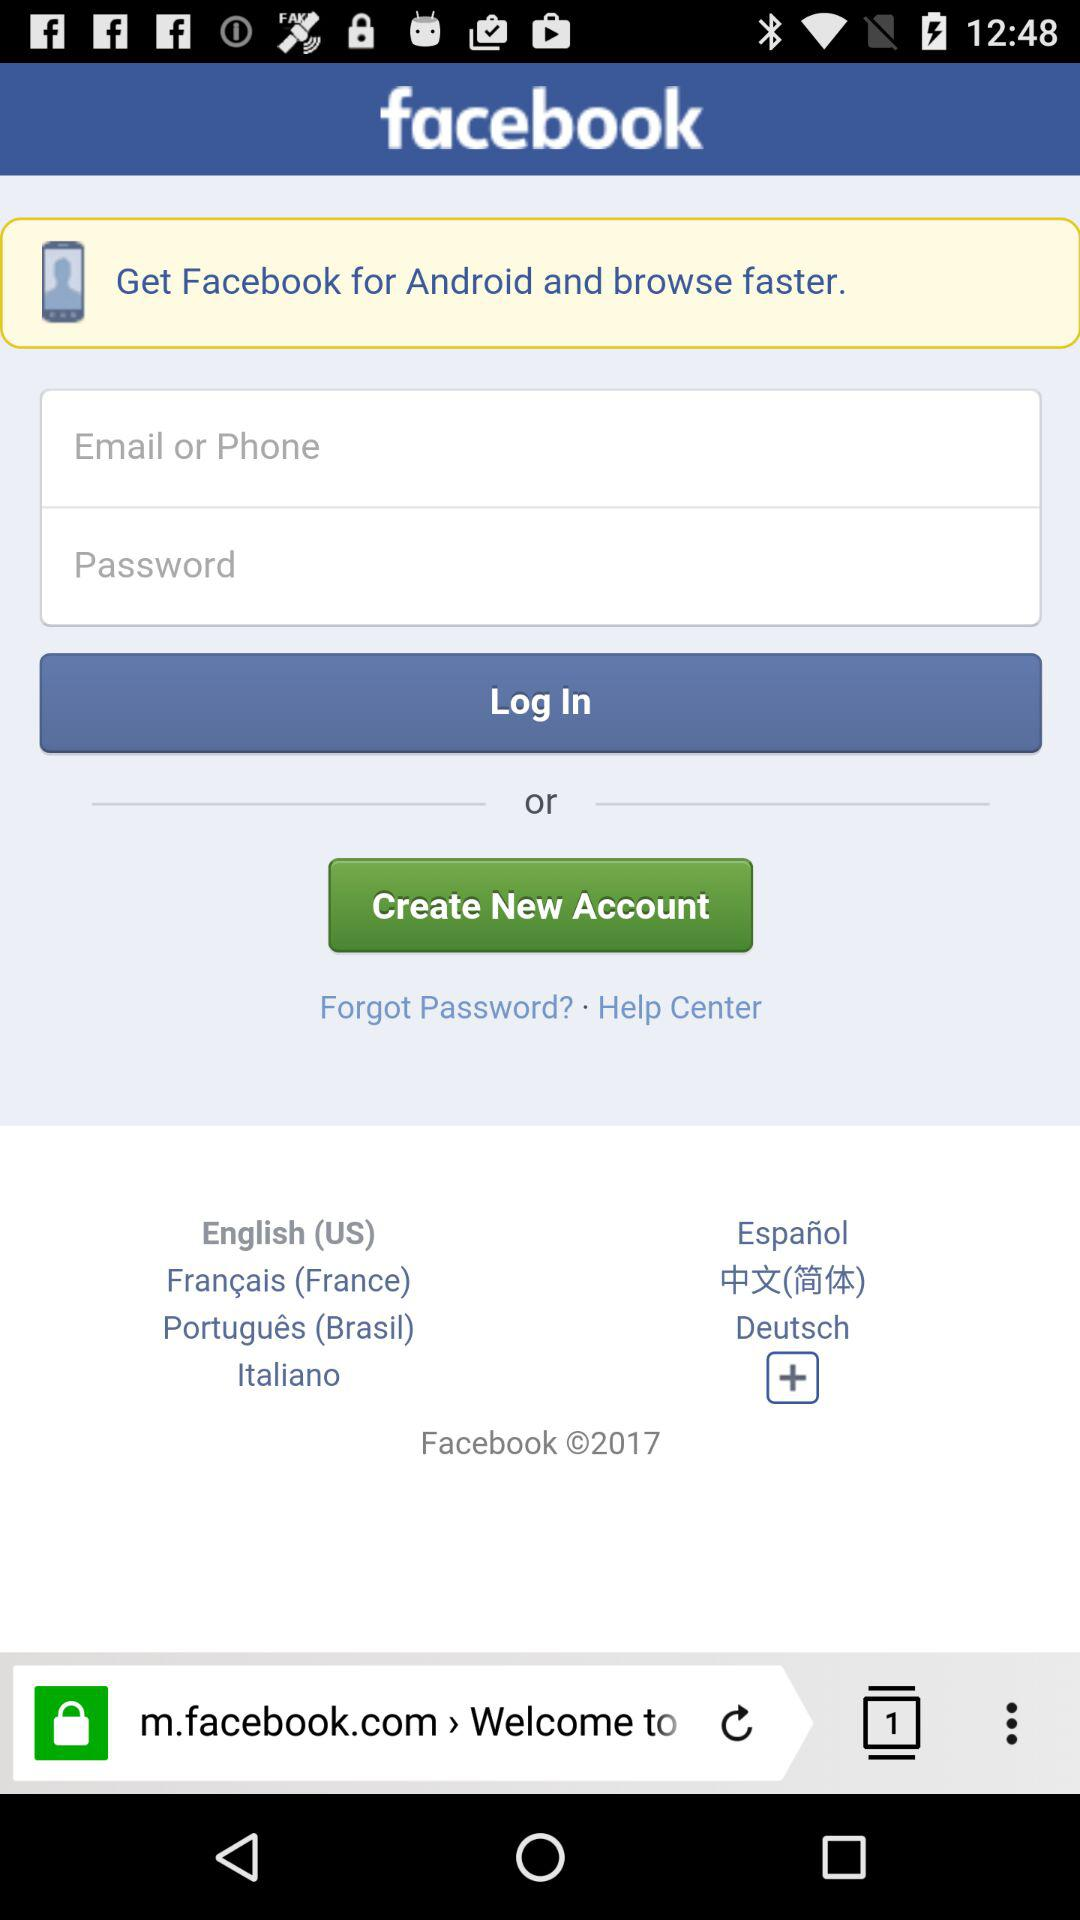How many languages are available for selection?
Answer the question using a single word or phrase. 7 